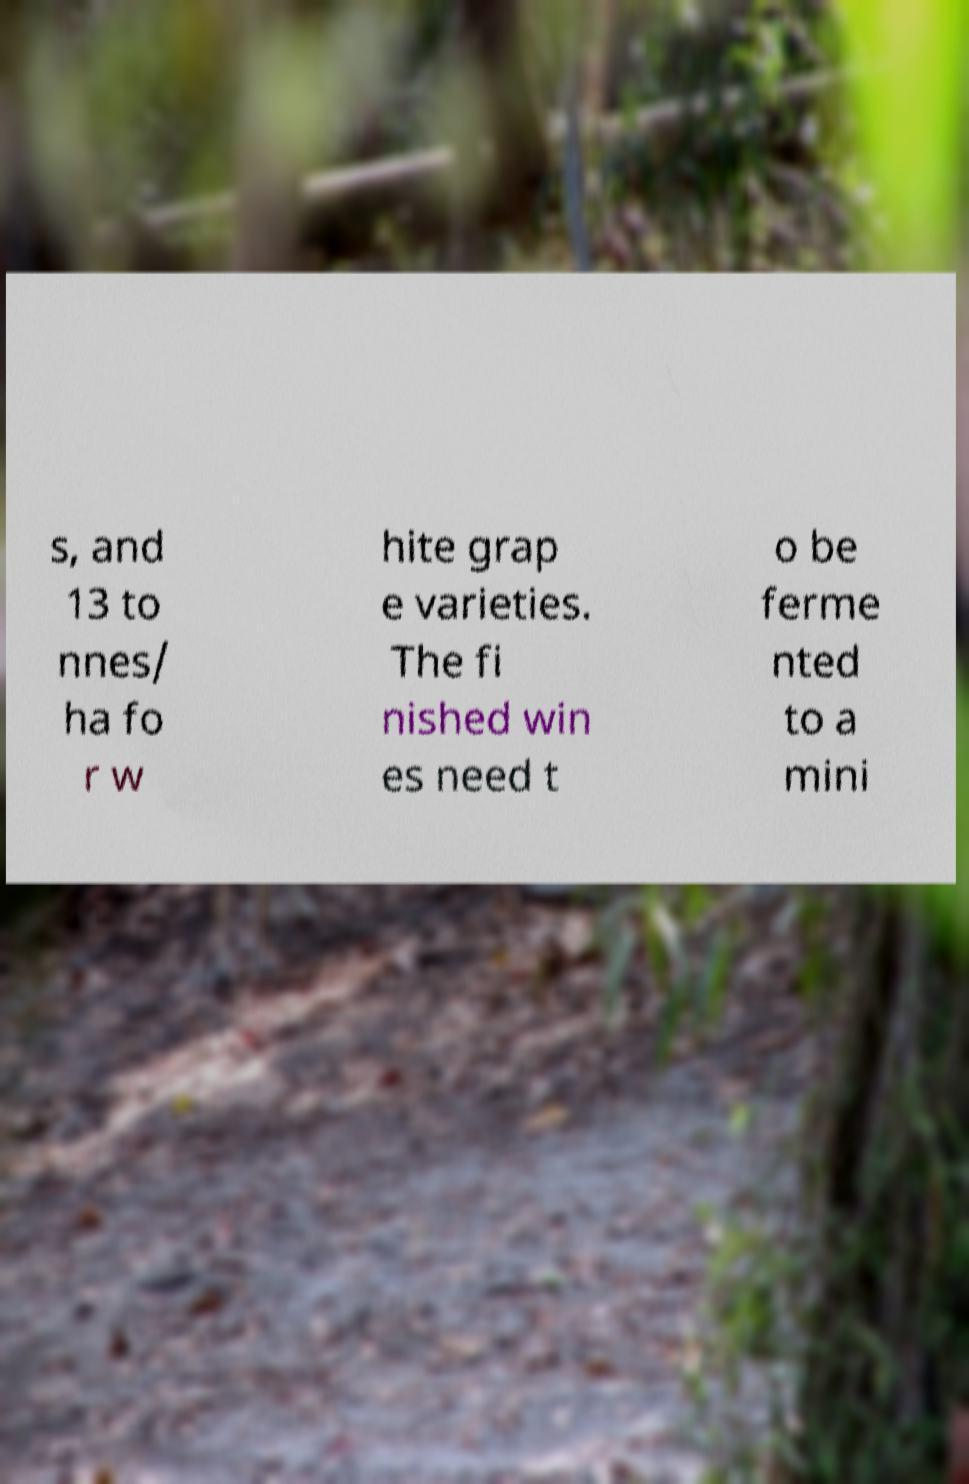Can you tell me more about what these numbers might refer to in the context of winemaking? The numbers '13 to' and 'nnes/ ha' likely refer to measurements of yield, possibly indicating 13 tonnes per hectare, which is a unit of measure commonly used to indicate the amount of grapes harvested per hectare of vineyard. This is a key factor in determining the potential quantity of wine that can be produced. 